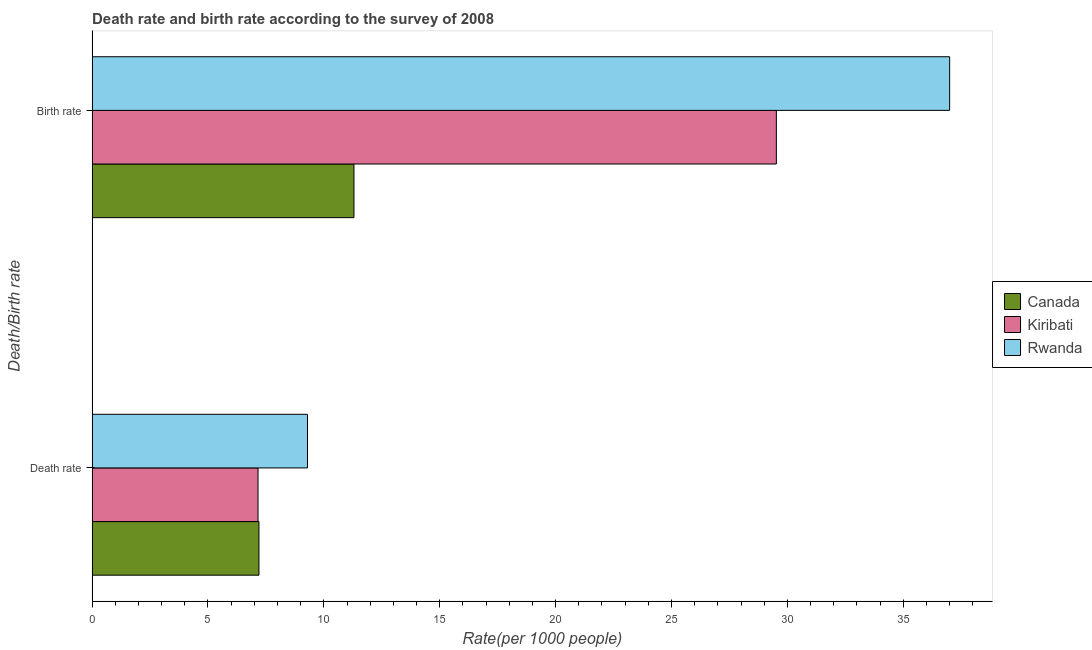How many different coloured bars are there?
Make the answer very short. 3. Are the number of bars per tick equal to the number of legend labels?
Your answer should be compact. Yes. How many bars are there on the 2nd tick from the bottom?
Offer a terse response. 3. What is the label of the 2nd group of bars from the top?
Provide a short and direct response. Death rate. Across all countries, what is the maximum birth rate?
Ensure brevity in your answer.  37. Across all countries, what is the minimum birth rate?
Your answer should be very brief. 11.3. In which country was the death rate maximum?
Give a very brief answer. Rwanda. In which country was the death rate minimum?
Offer a very short reply. Kiribati. What is the total death rate in the graph?
Offer a very short reply. 23.65. What is the difference between the birth rate in Rwanda and that in Canada?
Ensure brevity in your answer.  25.7. What is the difference between the death rate in Kiribati and the birth rate in Canada?
Provide a succinct answer. -4.14. What is the average death rate per country?
Your answer should be very brief. 7.88. What is the difference between the birth rate and death rate in Kiribati?
Your response must be concise. 22.37. In how many countries, is the birth rate greater than 15 ?
Ensure brevity in your answer.  2. What is the ratio of the death rate in Kiribati to that in Canada?
Your answer should be very brief. 0.99. Is the death rate in Rwanda less than that in Canada?
Offer a terse response. No. In how many countries, is the birth rate greater than the average birth rate taken over all countries?
Ensure brevity in your answer.  2. What does the 3rd bar from the top in Death rate represents?
Your response must be concise. Canada. What does the 1st bar from the bottom in Death rate represents?
Make the answer very short. Canada. How many bars are there?
Ensure brevity in your answer.  6. Are all the bars in the graph horizontal?
Give a very brief answer. Yes. Are the values on the major ticks of X-axis written in scientific E-notation?
Provide a short and direct response. No. How many legend labels are there?
Make the answer very short. 3. How are the legend labels stacked?
Your response must be concise. Vertical. What is the title of the graph?
Offer a very short reply. Death rate and birth rate according to the survey of 2008. What is the label or title of the X-axis?
Your response must be concise. Rate(per 1000 people). What is the label or title of the Y-axis?
Give a very brief answer. Death/Birth rate. What is the Rate(per 1000 people) in Canada in Death rate?
Your answer should be very brief. 7.2. What is the Rate(per 1000 people) in Kiribati in Death rate?
Give a very brief answer. 7.16. What is the Rate(per 1000 people) of Rwanda in Death rate?
Give a very brief answer. 9.29. What is the Rate(per 1000 people) of Canada in Birth rate?
Ensure brevity in your answer.  11.3. What is the Rate(per 1000 people) of Kiribati in Birth rate?
Ensure brevity in your answer.  29.53. What is the Rate(per 1000 people) of Rwanda in Birth rate?
Provide a short and direct response. 37. Across all Death/Birth rate, what is the maximum Rate(per 1000 people) in Canada?
Your answer should be very brief. 11.3. Across all Death/Birth rate, what is the maximum Rate(per 1000 people) of Kiribati?
Make the answer very short. 29.53. Across all Death/Birth rate, what is the maximum Rate(per 1000 people) in Rwanda?
Your answer should be compact. 37. Across all Death/Birth rate, what is the minimum Rate(per 1000 people) of Canada?
Give a very brief answer. 7.2. Across all Death/Birth rate, what is the minimum Rate(per 1000 people) of Kiribati?
Provide a short and direct response. 7.16. Across all Death/Birth rate, what is the minimum Rate(per 1000 people) of Rwanda?
Your response must be concise. 9.29. What is the total Rate(per 1000 people) in Kiribati in the graph?
Provide a short and direct response. 36.69. What is the total Rate(per 1000 people) of Rwanda in the graph?
Give a very brief answer. 46.3. What is the difference between the Rate(per 1000 people) of Canada in Death rate and that in Birth rate?
Ensure brevity in your answer.  -4.1. What is the difference between the Rate(per 1000 people) of Kiribati in Death rate and that in Birth rate?
Your answer should be very brief. -22.37. What is the difference between the Rate(per 1000 people) in Rwanda in Death rate and that in Birth rate?
Make the answer very short. -27.71. What is the difference between the Rate(per 1000 people) of Canada in Death rate and the Rate(per 1000 people) of Kiribati in Birth rate?
Your answer should be very brief. -22.33. What is the difference between the Rate(per 1000 people) in Canada in Death rate and the Rate(per 1000 people) in Rwanda in Birth rate?
Give a very brief answer. -29.8. What is the difference between the Rate(per 1000 people) in Kiribati in Death rate and the Rate(per 1000 people) in Rwanda in Birth rate?
Provide a succinct answer. -29.84. What is the average Rate(per 1000 people) of Canada per Death/Birth rate?
Your response must be concise. 9.25. What is the average Rate(per 1000 people) of Kiribati per Death/Birth rate?
Offer a very short reply. 18.34. What is the average Rate(per 1000 people) in Rwanda per Death/Birth rate?
Your answer should be very brief. 23.15. What is the difference between the Rate(per 1000 people) of Canada and Rate(per 1000 people) of Kiribati in Death rate?
Give a very brief answer. 0.04. What is the difference between the Rate(per 1000 people) of Canada and Rate(per 1000 people) of Rwanda in Death rate?
Your response must be concise. -2.09. What is the difference between the Rate(per 1000 people) in Kiribati and Rate(per 1000 people) in Rwanda in Death rate?
Offer a terse response. -2.13. What is the difference between the Rate(per 1000 people) of Canada and Rate(per 1000 people) of Kiribati in Birth rate?
Offer a terse response. -18.23. What is the difference between the Rate(per 1000 people) in Canada and Rate(per 1000 people) in Rwanda in Birth rate?
Offer a very short reply. -25.7. What is the difference between the Rate(per 1000 people) of Kiribati and Rate(per 1000 people) of Rwanda in Birth rate?
Provide a short and direct response. -7.48. What is the ratio of the Rate(per 1000 people) in Canada in Death rate to that in Birth rate?
Provide a short and direct response. 0.64. What is the ratio of the Rate(per 1000 people) of Kiribati in Death rate to that in Birth rate?
Your response must be concise. 0.24. What is the ratio of the Rate(per 1000 people) of Rwanda in Death rate to that in Birth rate?
Provide a succinct answer. 0.25. What is the difference between the highest and the second highest Rate(per 1000 people) of Kiribati?
Provide a short and direct response. 22.37. What is the difference between the highest and the second highest Rate(per 1000 people) in Rwanda?
Give a very brief answer. 27.71. What is the difference between the highest and the lowest Rate(per 1000 people) in Canada?
Your answer should be very brief. 4.1. What is the difference between the highest and the lowest Rate(per 1000 people) of Kiribati?
Your answer should be compact. 22.37. What is the difference between the highest and the lowest Rate(per 1000 people) of Rwanda?
Provide a succinct answer. 27.71. 